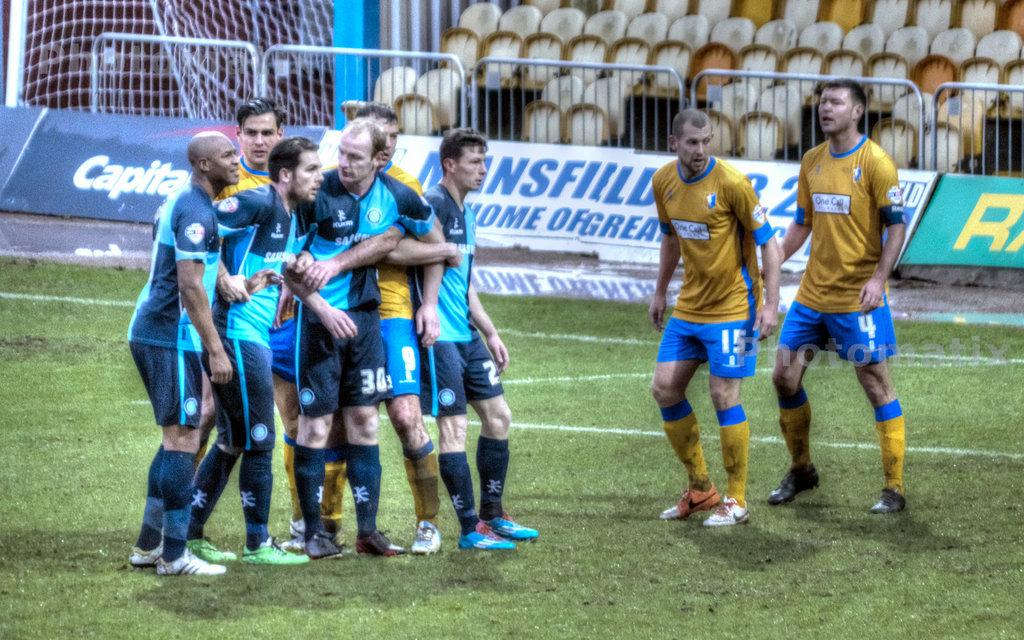What is the setting of the image? The men are standing on grassland. What can be seen in the background? There are posters, chairs, and a net in the background. What type of paint is being used on the houses in the image? There are no houses present in the image, so it is not possible to determine what type of paint is being used. 